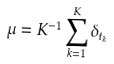Convert formula to latex. <formula><loc_0><loc_0><loc_500><loc_500>\mu = K ^ { - 1 } \sum _ { k = 1 } ^ { K } \delta _ { t _ { k } }</formula> 